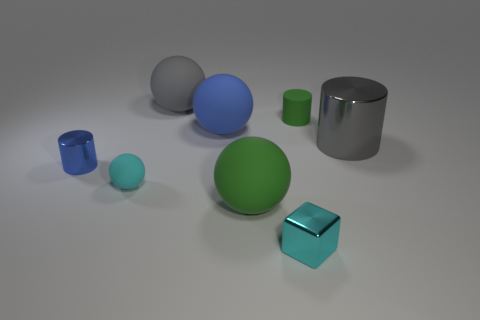Add 1 big purple matte cylinders. How many objects exist? 9 Subtract all cubes. How many objects are left? 7 Add 6 tiny cyan things. How many tiny cyan things are left? 8 Add 4 small blue objects. How many small blue objects exist? 5 Subtract 0 brown cubes. How many objects are left? 8 Subtract all big purple rubber cylinders. Subtract all small cyan rubber spheres. How many objects are left? 7 